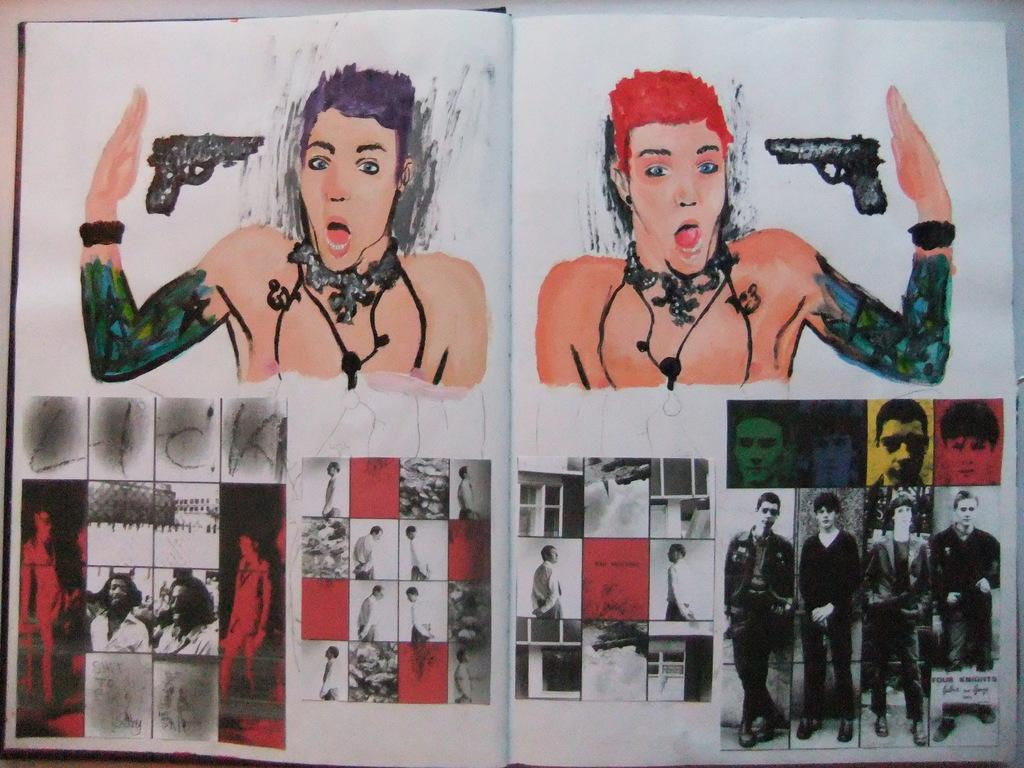What is on the cover of the book in the image? There is a painting on the book. What does the painting depict? The painting depicts persons and objects. What else can be found inside the book? There are photos on the pages of the book. What type of friction can be seen between the persons in the painting? There is no friction present in the painting, as it is a static image and not a physical interaction. 